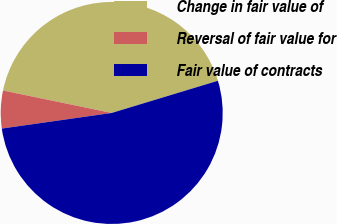Convert chart. <chart><loc_0><loc_0><loc_500><loc_500><pie_chart><fcel>Change in fair value of<fcel>Reversal of fair value for<fcel>Fair value of contracts<nl><fcel>42.07%<fcel>5.49%<fcel>52.44%<nl></chart> 